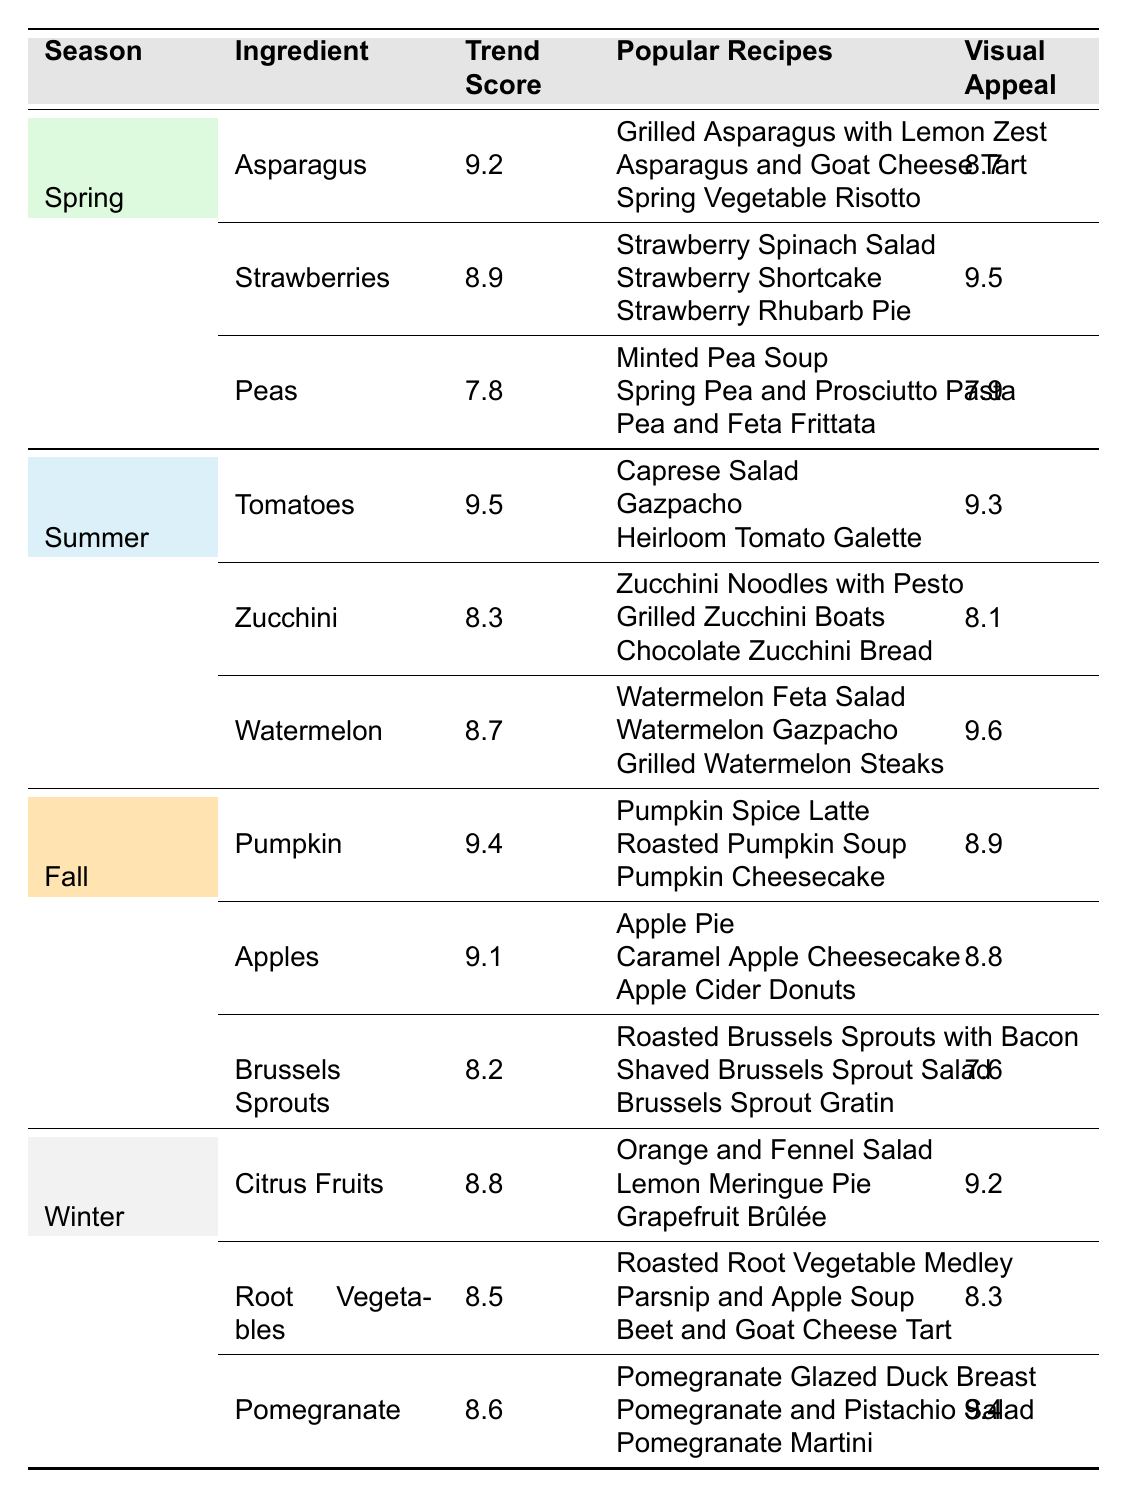What are the top three ingredients in spring? According to the table, the top three ingredients in spring are Asparagus, Strawberries, and Peas.
Answer: Asparagus, Strawberries, Peas Which ingredient has the highest trend score in summer? The table shows that Tomatoes have the highest trend score in summer at 9.5.
Answer: Tomatoes Is Watermelon more visually appealing than Zucchini? Yes, Watermelon has a visual appeal score of 9.6, while Zucchini has a score of 8.1.
Answer: Yes What is the average trend score of the ingredients in fall? The trend scores for fall are 9.4 (Pumpkin), 9.1 (Apples), and 8.2 (Brussels Sprouts). The average is (9.4 + 9.1 + 8.2) / 3 = 8.88.
Answer: 8.88 Does Citrus Fruits have a better visual appeal score than Root Vegetables? Yes, Citrus Fruits have a visual appeal score of 9.2, while Root Vegetables have a score of 8.3.
Answer: Yes Which season has the lowest average visual appeal score? First, we need to calculate the average visual appeal scores for each season: Spring (8.7 + 9.5 + 7.9)/3 = 8.7, Summer (9.3 + 8.1 + 9.6)/3 = 9.0, Fall (8.9 + 8.8 + 7.6)/3 = 8.78, Winter (9.2 + 8.3 + 9.4)/3 = 8.93. Fall is the lowest at 8.78.
Answer: Fall What recipes are commonly used with Pomegranate? The table lists the popular recipes with Pomegranate as Pomegranate Glazed Duck Breast, Pomegranate and Pistachio Salad, and Pomegranate Martini.
Answer: Pomegranate Glazed Duck Breast, Pomegranate and Pistachio Salad, Pomegranate Martini What is the trend score difference between Pumpkin and Apples? The trend score for Pumpkin is 9.4, and for Apples, it is 9.1. The difference is 9.4 - 9.1 = 0.3.
Answer: 0.3 Are Strawberries more trendy than Peas? Yes, Strawberries have a trend score of 8.9, while Peas have a score of 7.8.
Answer: Yes 